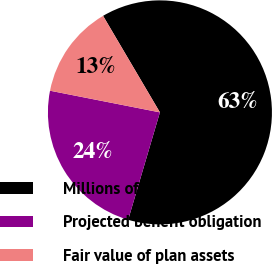<chart> <loc_0><loc_0><loc_500><loc_500><pie_chart><fcel>Millions of dollars<fcel>Projected benefit obligation<fcel>Fair value of plan assets<nl><fcel>63.04%<fcel>23.52%<fcel>13.43%<nl></chart> 